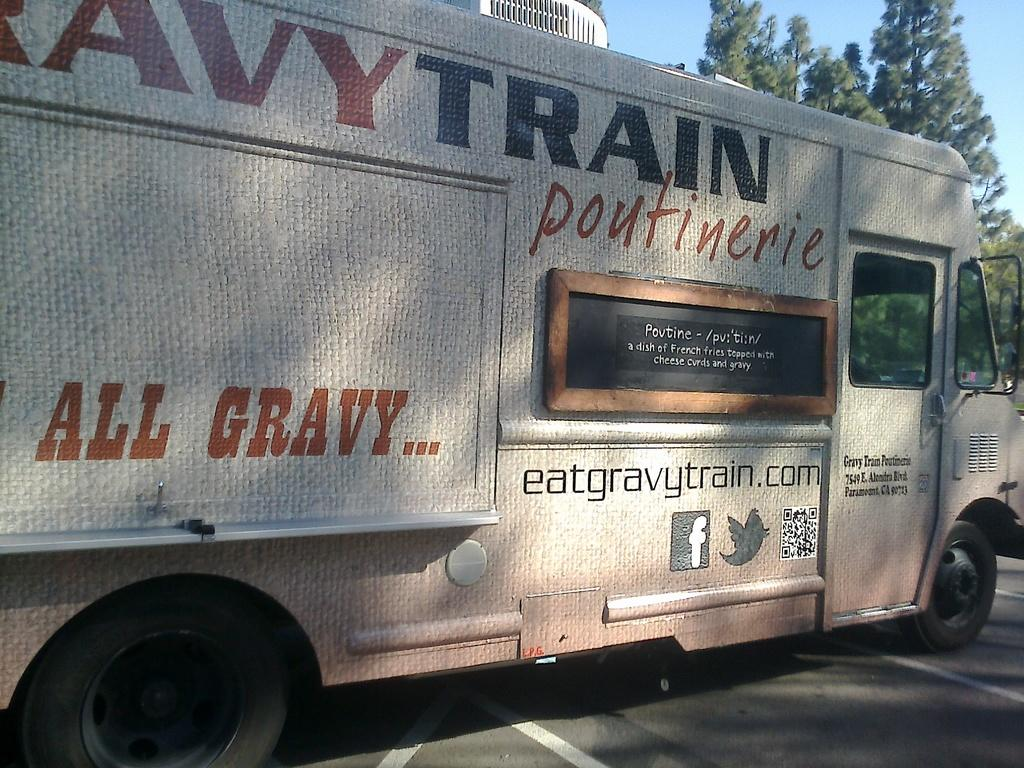What is the main subject of the image? There is a vehicle on the road in the image. What can be seen on the road in the image? There are white lines visible on the road. What type of natural elements are present in the background of the image? There are trees in the background of the image. What part of the natural environment is visible in the background of the image? The sky is visible in the background of the image. What type of alarm can be heard going off in the image? There is no alarm present in the image, and therefore no such sound can be heard. 